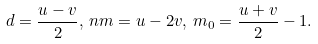Convert formula to latex. <formula><loc_0><loc_0><loc_500><loc_500>d = \frac { u - v } { 2 } , \, n m = u - 2 v , \, m _ { 0 } = \frac { u + v } { 2 } - 1 .</formula> 